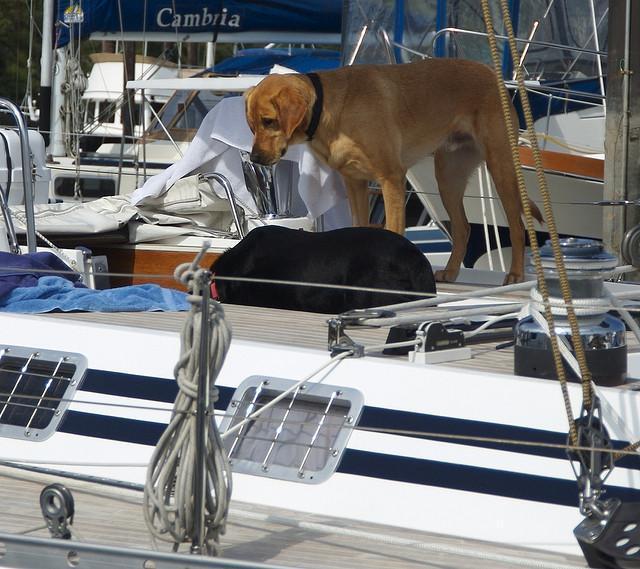How many dogs are on the boat?
Give a very brief answer. 2. How many boats are there?
Give a very brief answer. 3. How many dogs are in the photo?
Give a very brief answer. 2. How many zebras have all of their feet in the grass?
Give a very brief answer. 0. 